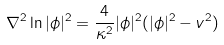<formula> <loc_0><loc_0><loc_500><loc_500>\nabla ^ { 2 } \ln | \phi | ^ { 2 } = \frac { 4 } { \kappa ^ { 2 } } | \phi | ^ { 2 } ( | \phi | ^ { 2 } - v ^ { 2 } )</formula> 